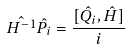Convert formula to latex. <formula><loc_0><loc_0><loc_500><loc_500>\hat { H ^ { - 1 } } \hat { P _ { i } } = \frac { [ \hat { Q _ { i } } , \hat { H } ] } { i }</formula> 